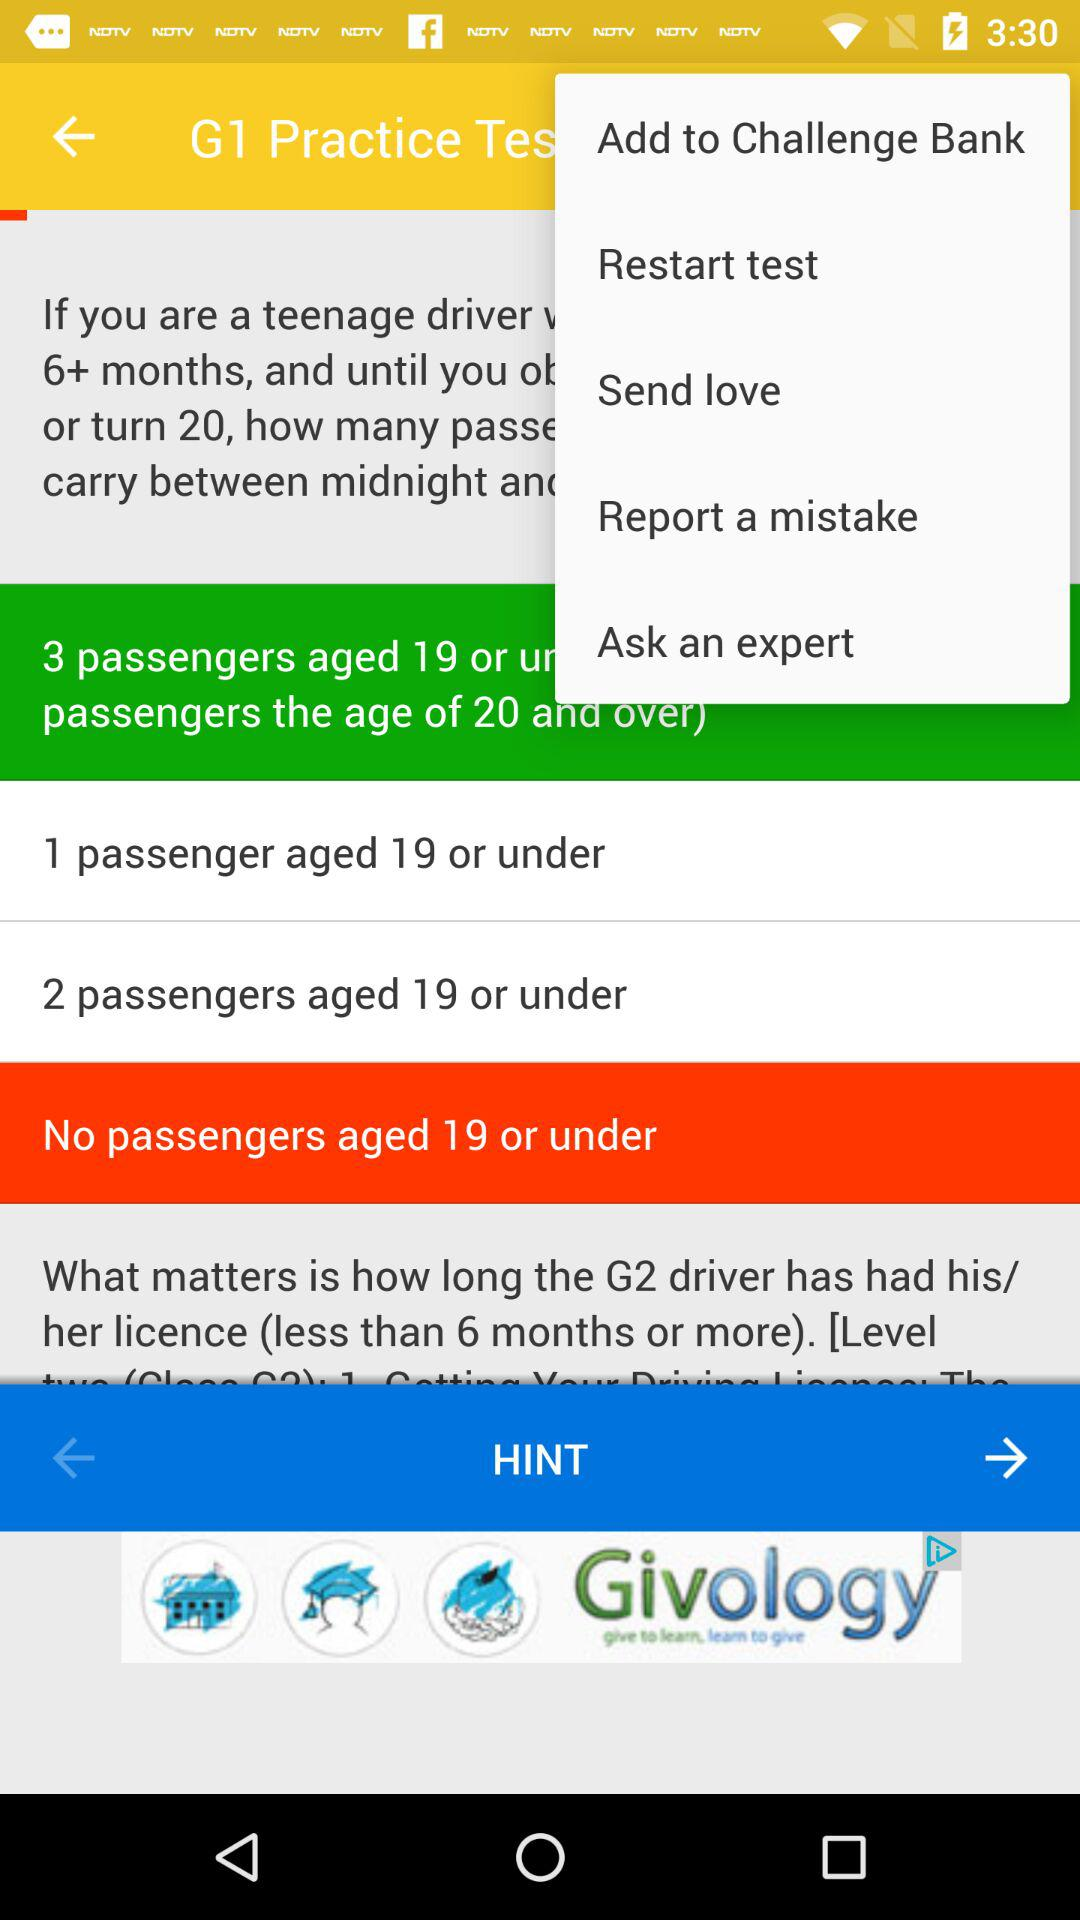Which option is selected?
When the provided information is insufficient, respond with <no answer>. <no answer> 